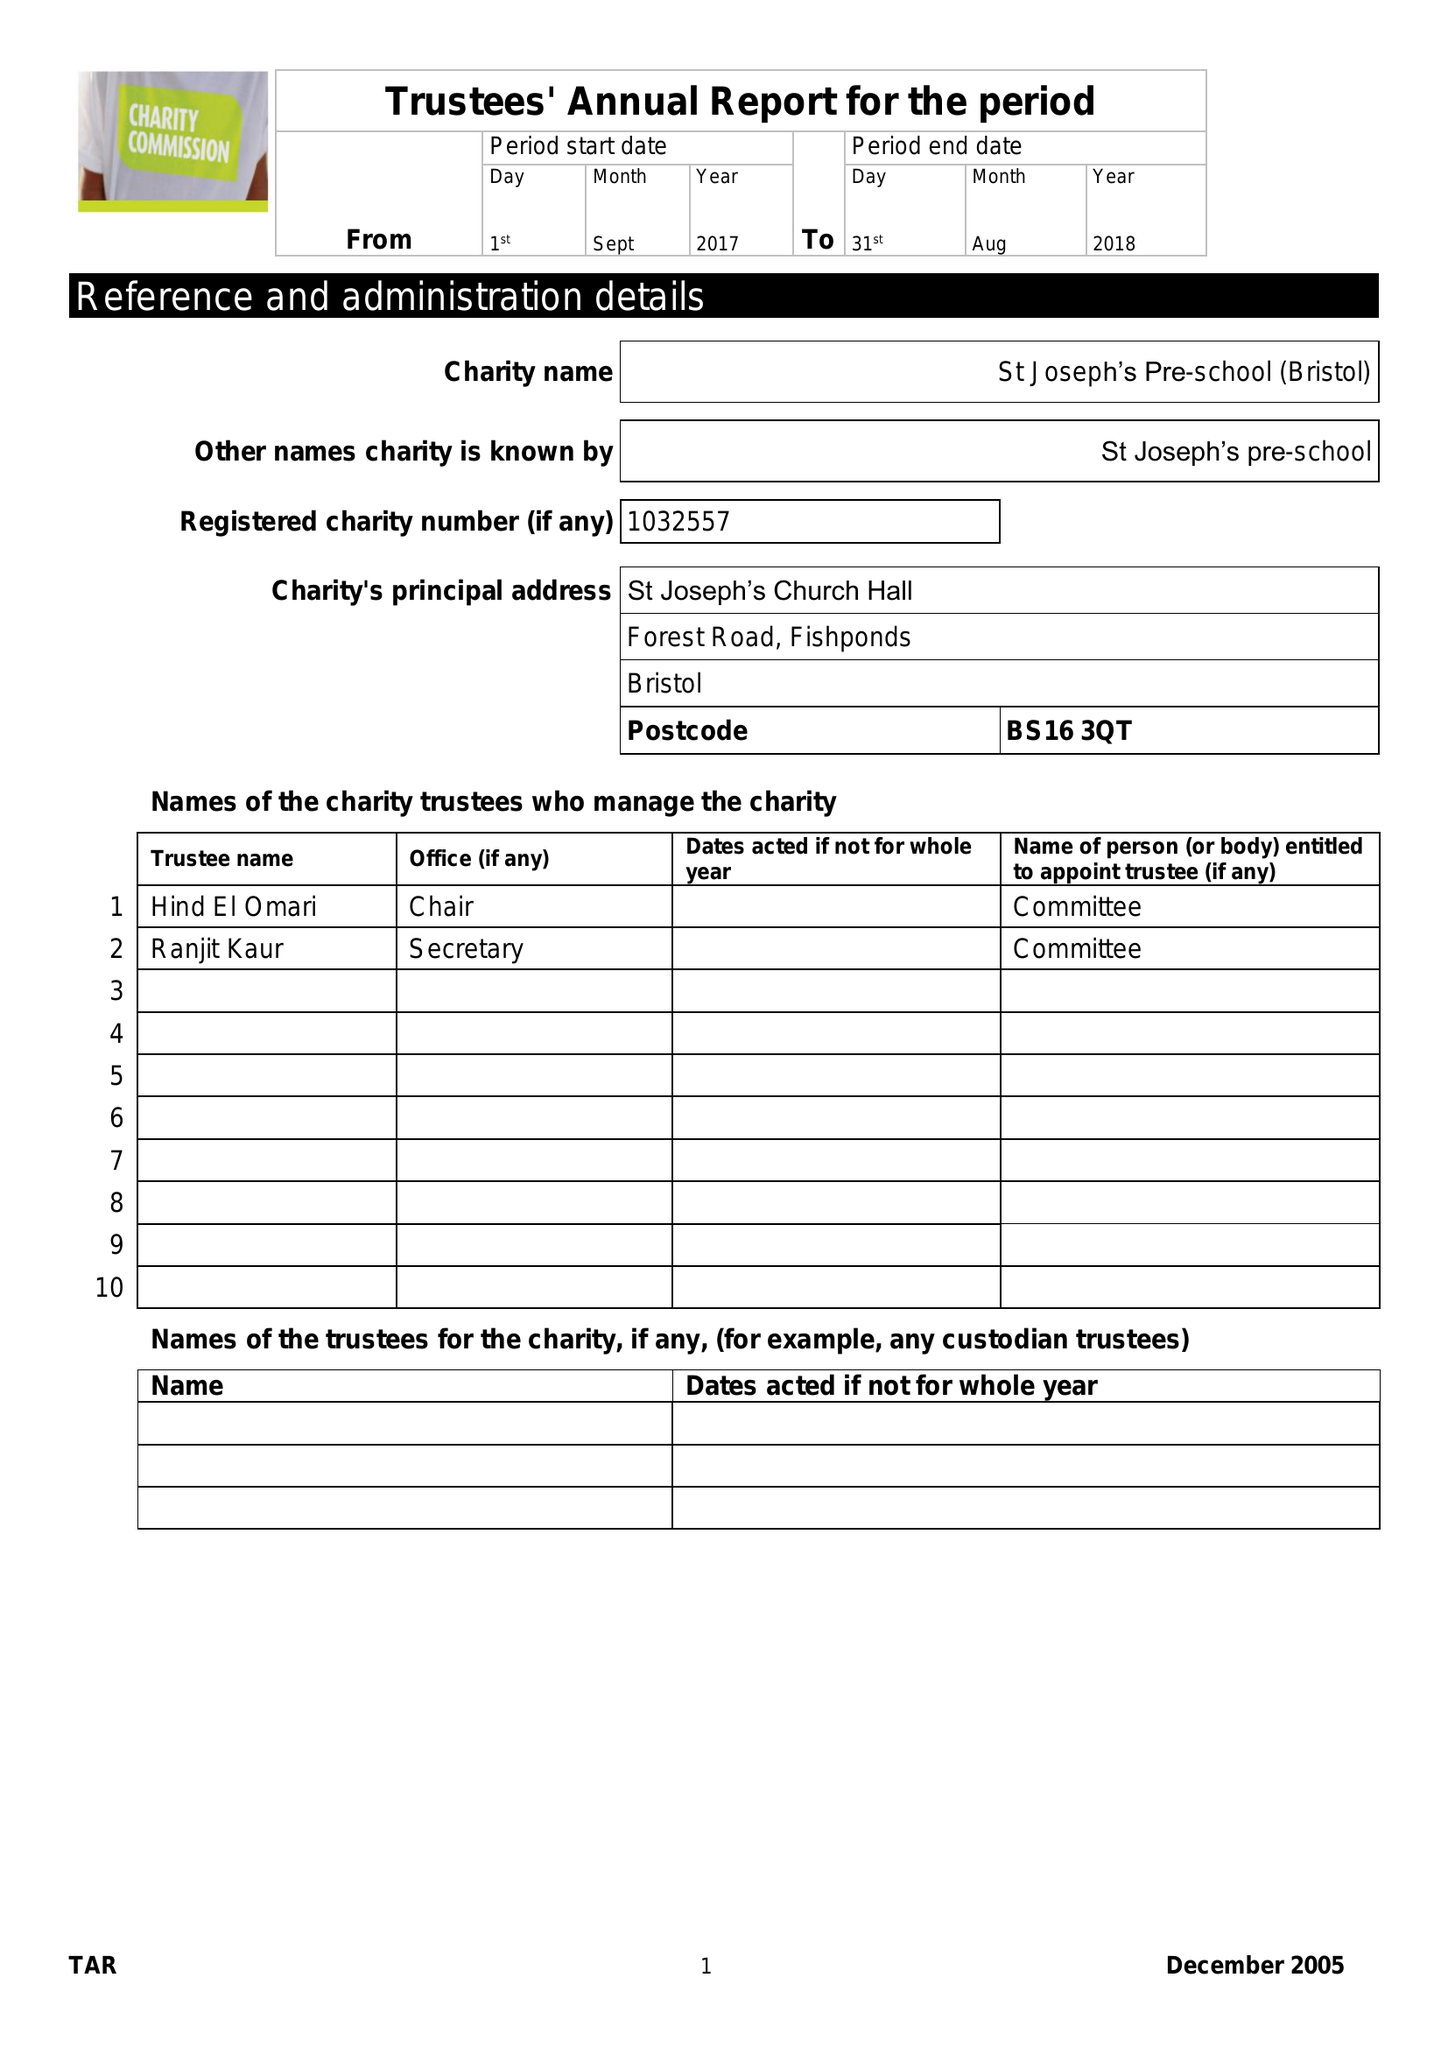What is the value for the charity_name?
Answer the question using a single word or phrase. St Josephs Pre-School (Bristol) 